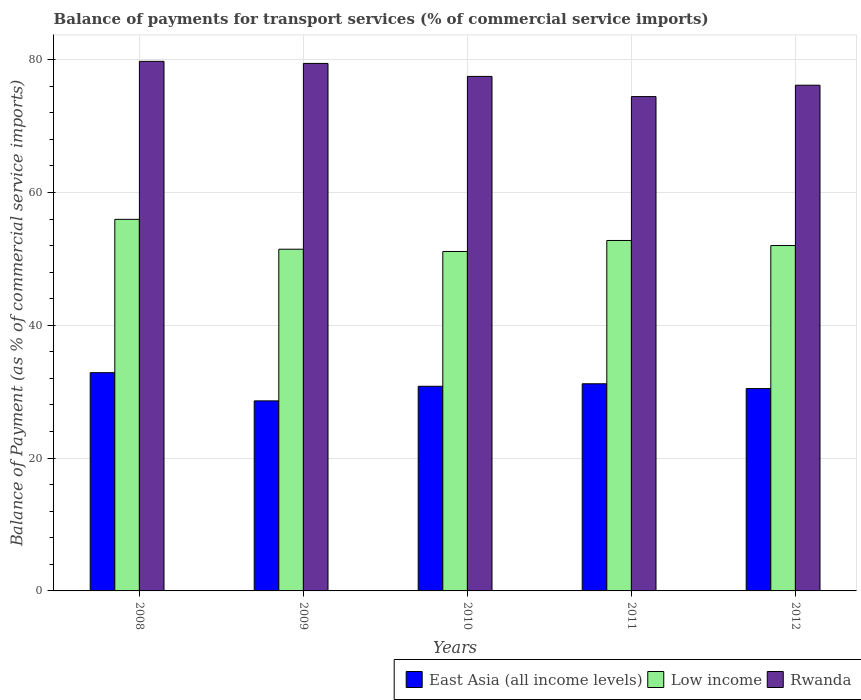How many different coloured bars are there?
Provide a succinct answer. 3. How many groups of bars are there?
Your answer should be very brief. 5. How many bars are there on the 1st tick from the right?
Your answer should be compact. 3. What is the balance of payments for transport services in Low income in 2011?
Make the answer very short. 52.78. Across all years, what is the maximum balance of payments for transport services in Low income?
Make the answer very short. 55.96. Across all years, what is the minimum balance of payments for transport services in East Asia (all income levels)?
Ensure brevity in your answer.  28.62. In which year was the balance of payments for transport services in East Asia (all income levels) maximum?
Provide a succinct answer. 2008. What is the total balance of payments for transport services in East Asia (all income levels) in the graph?
Make the answer very short. 153.97. What is the difference between the balance of payments for transport services in Rwanda in 2009 and that in 2010?
Provide a succinct answer. 1.96. What is the difference between the balance of payments for transport services in Rwanda in 2008 and the balance of payments for transport services in Low income in 2010?
Your response must be concise. 28.63. What is the average balance of payments for transport services in Rwanda per year?
Your answer should be compact. 77.45. In the year 2008, what is the difference between the balance of payments for transport services in East Asia (all income levels) and balance of payments for transport services in Rwanda?
Your answer should be compact. -46.88. In how many years, is the balance of payments for transport services in Low income greater than 48 %?
Offer a very short reply. 5. What is the ratio of the balance of payments for transport services in Low income in 2010 to that in 2011?
Ensure brevity in your answer.  0.97. What is the difference between the highest and the second highest balance of payments for transport services in Low income?
Ensure brevity in your answer.  3.18. What is the difference between the highest and the lowest balance of payments for transport services in Rwanda?
Ensure brevity in your answer.  5.31. What does the 3rd bar from the left in 2011 represents?
Provide a succinct answer. Rwanda. What does the 1st bar from the right in 2010 represents?
Your answer should be compact. Rwanda. Are the values on the major ticks of Y-axis written in scientific E-notation?
Offer a very short reply. No. Does the graph contain any zero values?
Offer a very short reply. No. Does the graph contain grids?
Offer a terse response. Yes. What is the title of the graph?
Offer a very short reply. Balance of payments for transport services (% of commercial service imports). Does "Andorra" appear as one of the legend labels in the graph?
Give a very brief answer. No. What is the label or title of the X-axis?
Your response must be concise. Years. What is the label or title of the Y-axis?
Give a very brief answer. Balance of Payment (as % of commercial service imports). What is the Balance of Payment (as % of commercial service imports) of East Asia (all income levels) in 2008?
Offer a terse response. 32.87. What is the Balance of Payment (as % of commercial service imports) of Low income in 2008?
Offer a very short reply. 55.96. What is the Balance of Payment (as % of commercial service imports) of Rwanda in 2008?
Your response must be concise. 79.75. What is the Balance of Payment (as % of commercial service imports) of East Asia (all income levels) in 2009?
Give a very brief answer. 28.62. What is the Balance of Payment (as % of commercial service imports) of Low income in 2009?
Your answer should be very brief. 51.46. What is the Balance of Payment (as % of commercial service imports) in Rwanda in 2009?
Make the answer very short. 79.44. What is the Balance of Payment (as % of commercial service imports) of East Asia (all income levels) in 2010?
Offer a very short reply. 30.82. What is the Balance of Payment (as % of commercial service imports) of Low income in 2010?
Your answer should be very brief. 51.12. What is the Balance of Payment (as % of commercial service imports) in Rwanda in 2010?
Provide a short and direct response. 77.48. What is the Balance of Payment (as % of commercial service imports) of East Asia (all income levels) in 2011?
Ensure brevity in your answer.  31.2. What is the Balance of Payment (as % of commercial service imports) of Low income in 2011?
Provide a short and direct response. 52.78. What is the Balance of Payment (as % of commercial service imports) of Rwanda in 2011?
Provide a short and direct response. 74.44. What is the Balance of Payment (as % of commercial service imports) in East Asia (all income levels) in 2012?
Offer a terse response. 30.47. What is the Balance of Payment (as % of commercial service imports) in Low income in 2012?
Your response must be concise. 52.01. What is the Balance of Payment (as % of commercial service imports) of Rwanda in 2012?
Your answer should be very brief. 76.15. Across all years, what is the maximum Balance of Payment (as % of commercial service imports) of East Asia (all income levels)?
Give a very brief answer. 32.87. Across all years, what is the maximum Balance of Payment (as % of commercial service imports) of Low income?
Provide a succinct answer. 55.96. Across all years, what is the maximum Balance of Payment (as % of commercial service imports) in Rwanda?
Make the answer very short. 79.75. Across all years, what is the minimum Balance of Payment (as % of commercial service imports) in East Asia (all income levels)?
Your response must be concise. 28.62. Across all years, what is the minimum Balance of Payment (as % of commercial service imports) in Low income?
Your response must be concise. 51.12. Across all years, what is the minimum Balance of Payment (as % of commercial service imports) in Rwanda?
Give a very brief answer. 74.44. What is the total Balance of Payment (as % of commercial service imports) in East Asia (all income levels) in the graph?
Give a very brief answer. 153.97. What is the total Balance of Payment (as % of commercial service imports) in Low income in the graph?
Provide a succinct answer. 263.32. What is the total Balance of Payment (as % of commercial service imports) of Rwanda in the graph?
Make the answer very short. 387.26. What is the difference between the Balance of Payment (as % of commercial service imports) in East Asia (all income levels) in 2008 and that in 2009?
Your answer should be very brief. 4.25. What is the difference between the Balance of Payment (as % of commercial service imports) of Low income in 2008 and that in 2009?
Your response must be concise. 4.5. What is the difference between the Balance of Payment (as % of commercial service imports) of Rwanda in 2008 and that in 2009?
Provide a short and direct response. 0.31. What is the difference between the Balance of Payment (as % of commercial service imports) of East Asia (all income levels) in 2008 and that in 2010?
Give a very brief answer. 2.05. What is the difference between the Balance of Payment (as % of commercial service imports) in Low income in 2008 and that in 2010?
Make the answer very short. 4.84. What is the difference between the Balance of Payment (as % of commercial service imports) of Rwanda in 2008 and that in 2010?
Provide a short and direct response. 2.27. What is the difference between the Balance of Payment (as % of commercial service imports) in East Asia (all income levels) in 2008 and that in 2011?
Your answer should be compact. 1.67. What is the difference between the Balance of Payment (as % of commercial service imports) in Low income in 2008 and that in 2011?
Give a very brief answer. 3.18. What is the difference between the Balance of Payment (as % of commercial service imports) of Rwanda in 2008 and that in 2011?
Provide a short and direct response. 5.31. What is the difference between the Balance of Payment (as % of commercial service imports) of East Asia (all income levels) in 2008 and that in 2012?
Your response must be concise. 2.4. What is the difference between the Balance of Payment (as % of commercial service imports) of Low income in 2008 and that in 2012?
Offer a terse response. 3.94. What is the difference between the Balance of Payment (as % of commercial service imports) in Rwanda in 2008 and that in 2012?
Your response must be concise. 3.59. What is the difference between the Balance of Payment (as % of commercial service imports) in East Asia (all income levels) in 2009 and that in 2010?
Your answer should be compact. -2.2. What is the difference between the Balance of Payment (as % of commercial service imports) in Low income in 2009 and that in 2010?
Your response must be concise. 0.34. What is the difference between the Balance of Payment (as % of commercial service imports) of Rwanda in 2009 and that in 2010?
Ensure brevity in your answer.  1.96. What is the difference between the Balance of Payment (as % of commercial service imports) in East Asia (all income levels) in 2009 and that in 2011?
Give a very brief answer. -2.58. What is the difference between the Balance of Payment (as % of commercial service imports) of Low income in 2009 and that in 2011?
Your answer should be very brief. -1.32. What is the difference between the Balance of Payment (as % of commercial service imports) of Rwanda in 2009 and that in 2011?
Your answer should be very brief. 4.99. What is the difference between the Balance of Payment (as % of commercial service imports) in East Asia (all income levels) in 2009 and that in 2012?
Make the answer very short. -1.85. What is the difference between the Balance of Payment (as % of commercial service imports) of Low income in 2009 and that in 2012?
Keep it short and to the point. -0.55. What is the difference between the Balance of Payment (as % of commercial service imports) in Rwanda in 2009 and that in 2012?
Offer a very short reply. 3.28. What is the difference between the Balance of Payment (as % of commercial service imports) in East Asia (all income levels) in 2010 and that in 2011?
Offer a very short reply. -0.38. What is the difference between the Balance of Payment (as % of commercial service imports) of Low income in 2010 and that in 2011?
Offer a terse response. -1.66. What is the difference between the Balance of Payment (as % of commercial service imports) of Rwanda in 2010 and that in 2011?
Ensure brevity in your answer.  3.04. What is the difference between the Balance of Payment (as % of commercial service imports) in East Asia (all income levels) in 2010 and that in 2012?
Your answer should be very brief. 0.35. What is the difference between the Balance of Payment (as % of commercial service imports) in Low income in 2010 and that in 2012?
Give a very brief answer. -0.9. What is the difference between the Balance of Payment (as % of commercial service imports) in Rwanda in 2010 and that in 2012?
Your answer should be very brief. 1.33. What is the difference between the Balance of Payment (as % of commercial service imports) of East Asia (all income levels) in 2011 and that in 2012?
Offer a terse response. 0.72. What is the difference between the Balance of Payment (as % of commercial service imports) in Low income in 2011 and that in 2012?
Ensure brevity in your answer.  0.76. What is the difference between the Balance of Payment (as % of commercial service imports) in Rwanda in 2011 and that in 2012?
Your response must be concise. -1.71. What is the difference between the Balance of Payment (as % of commercial service imports) of East Asia (all income levels) in 2008 and the Balance of Payment (as % of commercial service imports) of Low income in 2009?
Your answer should be compact. -18.59. What is the difference between the Balance of Payment (as % of commercial service imports) of East Asia (all income levels) in 2008 and the Balance of Payment (as % of commercial service imports) of Rwanda in 2009?
Your response must be concise. -46.57. What is the difference between the Balance of Payment (as % of commercial service imports) of Low income in 2008 and the Balance of Payment (as % of commercial service imports) of Rwanda in 2009?
Make the answer very short. -23.48. What is the difference between the Balance of Payment (as % of commercial service imports) in East Asia (all income levels) in 2008 and the Balance of Payment (as % of commercial service imports) in Low income in 2010?
Give a very brief answer. -18.25. What is the difference between the Balance of Payment (as % of commercial service imports) in East Asia (all income levels) in 2008 and the Balance of Payment (as % of commercial service imports) in Rwanda in 2010?
Give a very brief answer. -44.61. What is the difference between the Balance of Payment (as % of commercial service imports) of Low income in 2008 and the Balance of Payment (as % of commercial service imports) of Rwanda in 2010?
Provide a short and direct response. -21.53. What is the difference between the Balance of Payment (as % of commercial service imports) in East Asia (all income levels) in 2008 and the Balance of Payment (as % of commercial service imports) in Low income in 2011?
Your response must be concise. -19.91. What is the difference between the Balance of Payment (as % of commercial service imports) of East Asia (all income levels) in 2008 and the Balance of Payment (as % of commercial service imports) of Rwanda in 2011?
Your response must be concise. -41.58. What is the difference between the Balance of Payment (as % of commercial service imports) in Low income in 2008 and the Balance of Payment (as % of commercial service imports) in Rwanda in 2011?
Give a very brief answer. -18.49. What is the difference between the Balance of Payment (as % of commercial service imports) of East Asia (all income levels) in 2008 and the Balance of Payment (as % of commercial service imports) of Low income in 2012?
Your response must be concise. -19.15. What is the difference between the Balance of Payment (as % of commercial service imports) in East Asia (all income levels) in 2008 and the Balance of Payment (as % of commercial service imports) in Rwanda in 2012?
Provide a short and direct response. -43.29. What is the difference between the Balance of Payment (as % of commercial service imports) in Low income in 2008 and the Balance of Payment (as % of commercial service imports) in Rwanda in 2012?
Offer a terse response. -20.2. What is the difference between the Balance of Payment (as % of commercial service imports) of East Asia (all income levels) in 2009 and the Balance of Payment (as % of commercial service imports) of Low income in 2010?
Your response must be concise. -22.5. What is the difference between the Balance of Payment (as % of commercial service imports) of East Asia (all income levels) in 2009 and the Balance of Payment (as % of commercial service imports) of Rwanda in 2010?
Give a very brief answer. -48.86. What is the difference between the Balance of Payment (as % of commercial service imports) of Low income in 2009 and the Balance of Payment (as % of commercial service imports) of Rwanda in 2010?
Your response must be concise. -26.02. What is the difference between the Balance of Payment (as % of commercial service imports) of East Asia (all income levels) in 2009 and the Balance of Payment (as % of commercial service imports) of Low income in 2011?
Keep it short and to the point. -24.16. What is the difference between the Balance of Payment (as % of commercial service imports) in East Asia (all income levels) in 2009 and the Balance of Payment (as % of commercial service imports) in Rwanda in 2011?
Your response must be concise. -45.82. What is the difference between the Balance of Payment (as % of commercial service imports) of Low income in 2009 and the Balance of Payment (as % of commercial service imports) of Rwanda in 2011?
Your response must be concise. -22.98. What is the difference between the Balance of Payment (as % of commercial service imports) of East Asia (all income levels) in 2009 and the Balance of Payment (as % of commercial service imports) of Low income in 2012?
Your response must be concise. -23.39. What is the difference between the Balance of Payment (as % of commercial service imports) of East Asia (all income levels) in 2009 and the Balance of Payment (as % of commercial service imports) of Rwanda in 2012?
Make the answer very short. -47.54. What is the difference between the Balance of Payment (as % of commercial service imports) of Low income in 2009 and the Balance of Payment (as % of commercial service imports) of Rwanda in 2012?
Ensure brevity in your answer.  -24.7. What is the difference between the Balance of Payment (as % of commercial service imports) of East Asia (all income levels) in 2010 and the Balance of Payment (as % of commercial service imports) of Low income in 2011?
Provide a short and direct response. -21.96. What is the difference between the Balance of Payment (as % of commercial service imports) of East Asia (all income levels) in 2010 and the Balance of Payment (as % of commercial service imports) of Rwanda in 2011?
Ensure brevity in your answer.  -43.63. What is the difference between the Balance of Payment (as % of commercial service imports) in Low income in 2010 and the Balance of Payment (as % of commercial service imports) in Rwanda in 2011?
Ensure brevity in your answer.  -23.33. What is the difference between the Balance of Payment (as % of commercial service imports) in East Asia (all income levels) in 2010 and the Balance of Payment (as % of commercial service imports) in Low income in 2012?
Keep it short and to the point. -21.19. What is the difference between the Balance of Payment (as % of commercial service imports) of East Asia (all income levels) in 2010 and the Balance of Payment (as % of commercial service imports) of Rwanda in 2012?
Your answer should be compact. -45.34. What is the difference between the Balance of Payment (as % of commercial service imports) in Low income in 2010 and the Balance of Payment (as % of commercial service imports) in Rwanda in 2012?
Make the answer very short. -25.04. What is the difference between the Balance of Payment (as % of commercial service imports) in East Asia (all income levels) in 2011 and the Balance of Payment (as % of commercial service imports) in Low income in 2012?
Offer a very short reply. -20.82. What is the difference between the Balance of Payment (as % of commercial service imports) in East Asia (all income levels) in 2011 and the Balance of Payment (as % of commercial service imports) in Rwanda in 2012?
Your answer should be very brief. -44.96. What is the difference between the Balance of Payment (as % of commercial service imports) of Low income in 2011 and the Balance of Payment (as % of commercial service imports) of Rwanda in 2012?
Give a very brief answer. -23.38. What is the average Balance of Payment (as % of commercial service imports) in East Asia (all income levels) per year?
Your answer should be very brief. 30.79. What is the average Balance of Payment (as % of commercial service imports) of Low income per year?
Keep it short and to the point. 52.66. What is the average Balance of Payment (as % of commercial service imports) of Rwanda per year?
Offer a very short reply. 77.45. In the year 2008, what is the difference between the Balance of Payment (as % of commercial service imports) in East Asia (all income levels) and Balance of Payment (as % of commercial service imports) in Low income?
Offer a terse response. -23.09. In the year 2008, what is the difference between the Balance of Payment (as % of commercial service imports) in East Asia (all income levels) and Balance of Payment (as % of commercial service imports) in Rwanda?
Provide a succinct answer. -46.88. In the year 2008, what is the difference between the Balance of Payment (as % of commercial service imports) in Low income and Balance of Payment (as % of commercial service imports) in Rwanda?
Your answer should be very brief. -23.79. In the year 2009, what is the difference between the Balance of Payment (as % of commercial service imports) in East Asia (all income levels) and Balance of Payment (as % of commercial service imports) in Low income?
Offer a very short reply. -22.84. In the year 2009, what is the difference between the Balance of Payment (as % of commercial service imports) of East Asia (all income levels) and Balance of Payment (as % of commercial service imports) of Rwanda?
Your answer should be compact. -50.82. In the year 2009, what is the difference between the Balance of Payment (as % of commercial service imports) of Low income and Balance of Payment (as % of commercial service imports) of Rwanda?
Your answer should be very brief. -27.98. In the year 2010, what is the difference between the Balance of Payment (as % of commercial service imports) of East Asia (all income levels) and Balance of Payment (as % of commercial service imports) of Low income?
Provide a succinct answer. -20.3. In the year 2010, what is the difference between the Balance of Payment (as % of commercial service imports) in East Asia (all income levels) and Balance of Payment (as % of commercial service imports) in Rwanda?
Your response must be concise. -46.66. In the year 2010, what is the difference between the Balance of Payment (as % of commercial service imports) of Low income and Balance of Payment (as % of commercial service imports) of Rwanda?
Offer a very short reply. -26.37. In the year 2011, what is the difference between the Balance of Payment (as % of commercial service imports) of East Asia (all income levels) and Balance of Payment (as % of commercial service imports) of Low income?
Your answer should be compact. -21.58. In the year 2011, what is the difference between the Balance of Payment (as % of commercial service imports) of East Asia (all income levels) and Balance of Payment (as % of commercial service imports) of Rwanda?
Your answer should be very brief. -43.25. In the year 2011, what is the difference between the Balance of Payment (as % of commercial service imports) of Low income and Balance of Payment (as % of commercial service imports) of Rwanda?
Give a very brief answer. -21.67. In the year 2012, what is the difference between the Balance of Payment (as % of commercial service imports) of East Asia (all income levels) and Balance of Payment (as % of commercial service imports) of Low income?
Your answer should be compact. -21.54. In the year 2012, what is the difference between the Balance of Payment (as % of commercial service imports) in East Asia (all income levels) and Balance of Payment (as % of commercial service imports) in Rwanda?
Your response must be concise. -45.68. In the year 2012, what is the difference between the Balance of Payment (as % of commercial service imports) of Low income and Balance of Payment (as % of commercial service imports) of Rwanda?
Provide a succinct answer. -24.14. What is the ratio of the Balance of Payment (as % of commercial service imports) in East Asia (all income levels) in 2008 to that in 2009?
Provide a short and direct response. 1.15. What is the ratio of the Balance of Payment (as % of commercial service imports) in Low income in 2008 to that in 2009?
Offer a terse response. 1.09. What is the ratio of the Balance of Payment (as % of commercial service imports) in East Asia (all income levels) in 2008 to that in 2010?
Provide a short and direct response. 1.07. What is the ratio of the Balance of Payment (as % of commercial service imports) in Low income in 2008 to that in 2010?
Offer a terse response. 1.09. What is the ratio of the Balance of Payment (as % of commercial service imports) in Rwanda in 2008 to that in 2010?
Offer a very short reply. 1.03. What is the ratio of the Balance of Payment (as % of commercial service imports) of East Asia (all income levels) in 2008 to that in 2011?
Ensure brevity in your answer.  1.05. What is the ratio of the Balance of Payment (as % of commercial service imports) in Low income in 2008 to that in 2011?
Offer a terse response. 1.06. What is the ratio of the Balance of Payment (as % of commercial service imports) in Rwanda in 2008 to that in 2011?
Provide a short and direct response. 1.07. What is the ratio of the Balance of Payment (as % of commercial service imports) in East Asia (all income levels) in 2008 to that in 2012?
Provide a short and direct response. 1.08. What is the ratio of the Balance of Payment (as % of commercial service imports) of Low income in 2008 to that in 2012?
Make the answer very short. 1.08. What is the ratio of the Balance of Payment (as % of commercial service imports) in Rwanda in 2008 to that in 2012?
Give a very brief answer. 1.05. What is the ratio of the Balance of Payment (as % of commercial service imports) of East Asia (all income levels) in 2009 to that in 2010?
Offer a very short reply. 0.93. What is the ratio of the Balance of Payment (as % of commercial service imports) in Rwanda in 2009 to that in 2010?
Keep it short and to the point. 1.03. What is the ratio of the Balance of Payment (as % of commercial service imports) in East Asia (all income levels) in 2009 to that in 2011?
Your answer should be compact. 0.92. What is the ratio of the Balance of Payment (as % of commercial service imports) in Low income in 2009 to that in 2011?
Keep it short and to the point. 0.98. What is the ratio of the Balance of Payment (as % of commercial service imports) in Rwanda in 2009 to that in 2011?
Provide a succinct answer. 1.07. What is the ratio of the Balance of Payment (as % of commercial service imports) of East Asia (all income levels) in 2009 to that in 2012?
Make the answer very short. 0.94. What is the ratio of the Balance of Payment (as % of commercial service imports) of Low income in 2009 to that in 2012?
Your answer should be very brief. 0.99. What is the ratio of the Balance of Payment (as % of commercial service imports) of Rwanda in 2009 to that in 2012?
Your answer should be very brief. 1.04. What is the ratio of the Balance of Payment (as % of commercial service imports) in East Asia (all income levels) in 2010 to that in 2011?
Your response must be concise. 0.99. What is the ratio of the Balance of Payment (as % of commercial service imports) in Low income in 2010 to that in 2011?
Provide a succinct answer. 0.97. What is the ratio of the Balance of Payment (as % of commercial service imports) in Rwanda in 2010 to that in 2011?
Keep it short and to the point. 1.04. What is the ratio of the Balance of Payment (as % of commercial service imports) in East Asia (all income levels) in 2010 to that in 2012?
Give a very brief answer. 1.01. What is the ratio of the Balance of Payment (as % of commercial service imports) in Low income in 2010 to that in 2012?
Give a very brief answer. 0.98. What is the ratio of the Balance of Payment (as % of commercial service imports) of Rwanda in 2010 to that in 2012?
Keep it short and to the point. 1.02. What is the ratio of the Balance of Payment (as % of commercial service imports) in East Asia (all income levels) in 2011 to that in 2012?
Offer a terse response. 1.02. What is the ratio of the Balance of Payment (as % of commercial service imports) of Low income in 2011 to that in 2012?
Give a very brief answer. 1.01. What is the ratio of the Balance of Payment (as % of commercial service imports) of Rwanda in 2011 to that in 2012?
Your answer should be compact. 0.98. What is the difference between the highest and the second highest Balance of Payment (as % of commercial service imports) in East Asia (all income levels)?
Make the answer very short. 1.67. What is the difference between the highest and the second highest Balance of Payment (as % of commercial service imports) in Low income?
Make the answer very short. 3.18. What is the difference between the highest and the second highest Balance of Payment (as % of commercial service imports) of Rwanda?
Provide a short and direct response. 0.31. What is the difference between the highest and the lowest Balance of Payment (as % of commercial service imports) of East Asia (all income levels)?
Make the answer very short. 4.25. What is the difference between the highest and the lowest Balance of Payment (as % of commercial service imports) of Low income?
Offer a very short reply. 4.84. What is the difference between the highest and the lowest Balance of Payment (as % of commercial service imports) of Rwanda?
Provide a short and direct response. 5.31. 